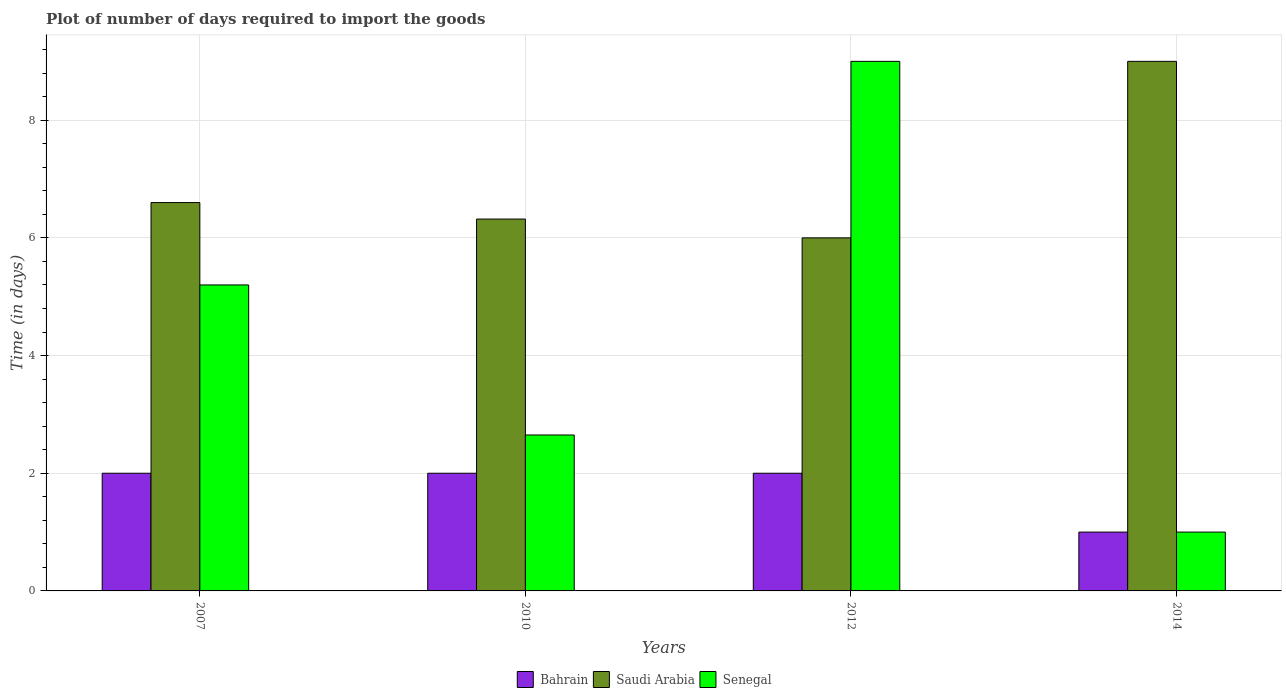How many groups of bars are there?
Offer a terse response. 4. How many bars are there on the 3rd tick from the left?
Your response must be concise. 3. In how many cases, is the number of bars for a given year not equal to the number of legend labels?
Keep it short and to the point. 0. Across all years, what is the maximum time required to import goods in Senegal?
Make the answer very short. 9. Across all years, what is the minimum time required to import goods in Bahrain?
Ensure brevity in your answer.  1. What is the total time required to import goods in Bahrain in the graph?
Your answer should be very brief. 7. What is the difference between the time required to import goods in Bahrain in 2010 and that in 2014?
Ensure brevity in your answer.  1. What is the average time required to import goods in Senegal per year?
Your answer should be very brief. 4.46. In the year 2012, what is the difference between the time required to import goods in Bahrain and time required to import goods in Saudi Arabia?
Keep it short and to the point. -4. In how many years, is the time required to import goods in Saudi Arabia greater than 7.6 days?
Your answer should be compact. 1. What is the ratio of the time required to import goods in Senegal in 2012 to that in 2014?
Give a very brief answer. 9. Is the difference between the time required to import goods in Bahrain in 2010 and 2014 greater than the difference between the time required to import goods in Saudi Arabia in 2010 and 2014?
Offer a terse response. Yes. What does the 1st bar from the left in 2012 represents?
Your answer should be very brief. Bahrain. What does the 2nd bar from the right in 2010 represents?
Offer a very short reply. Saudi Arabia. Is it the case that in every year, the sum of the time required to import goods in Saudi Arabia and time required to import goods in Senegal is greater than the time required to import goods in Bahrain?
Your response must be concise. Yes. Are all the bars in the graph horizontal?
Offer a terse response. No. How many years are there in the graph?
Your answer should be compact. 4. What is the difference between two consecutive major ticks on the Y-axis?
Ensure brevity in your answer.  2. Does the graph contain any zero values?
Ensure brevity in your answer.  No. Does the graph contain grids?
Your answer should be very brief. Yes. Where does the legend appear in the graph?
Provide a short and direct response. Bottom center. How many legend labels are there?
Ensure brevity in your answer.  3. What is the title of the graph?
Offer a very short reply. Plot of number of days required to import the goods. What is the label or title of the Y-axis?
Keep it short and to the point. Time (in days). What is the Time (in days) of Bahrain in 2007?
Ensure brevity in your answer.  2. What is the Time (in days) of Saudi Arabia in 2007?
Ensure brevity in your answer.  6.6. What is the Time (in days) in Saudi Arabia in 2010?
Make the answer very short. 6.32. What is the Time (in days) in Senegal in 2010?
Your response must be concise. 2.65. What is the Time (in days) in Bahrain in 2012?
Provide a succinct answer. 2. What is the Time (in days) in Saudi Arabia in 2012?
Offer a terse response. 6. What is the Time (in days) in Saudi Arabia in 2014?
Provide a succinct answer. 9. What is the Time (in days) of Senegal in 2014?
Provide a short and direct response. 1. Across all years, what is the maximum Time (in days) of Bahrain?
Give a very brief answer. 2. Across all years, what is the maximum Time (in days) in Saudi Arabia?
Keep it short and to the point. 9. Across all years, what is the minimum Time (in days) of Bahrain?
Provide a succinct answer. 1. Across all years, what is the minimum Time (in days) of Saudi Arabia?
Offer a very short reply. 6. Across all years, what is the minimum Time (in days) of Senegal?
Your response must be concise. 1. What is the total Time (in days) of Saudi Arabia in the graph?
Offer a very short reply. 27.92. What is the total Time (in days) in Senegal in the graph?
Give a very brief answer. 17.85. What is the difference between the Time (in days) in Bahrain in 2007 and that in 2010?
Offer a terse response. 0. What is the difference between the Time (in days) in Saudi Arabia in 2007 and that in 2010?
Your answer should be compact. 0.28. What is the difference between the Time (in days) in Senegal in 2007 and that in 2010?
Offer a very short reply. 2.55. What is the difference between the Time (in days) of Senegal in 2007 and that in 2012?
Your answer should be compact. -3.8. What is the difference between the Time (in days) of Saudi Arabia in 2007 and that in 2014?
Your response must be concise. -2.4. What is the difference between the Time (in days) in Senegal in 2007 and that in 2014?
Keep it short and to the point. 4.2. What is the difference between the Time (in days) in Saudi Arabia in 2010 and that in 2012?
Make the answer very short. 0.32. What is the difference between the Time (in days) in Senegal in 2010 and that in 2012?
Offer a very short reply. -6.35. What is the difference between the Time (in days) in Bahrain in 2010 and that in 2014?
Make the answer very short. 1. What is the difference between the Time (in days) in Saudi Arabia in 2010 and that in 2014?
Provide a short and direct response. -2.68. What is the difference between the Time (in days) of Senegal in 2010 and that in 2014?
Make the answer very short. 1.65. What is the difference between the Time (in days) in Bahrain in 2012 and that in 2014?
Ensure brevity in your answer.  1. What is the difference between the Time (in days) in Bahrain in 2007 and the Time (in days) in Saudi Arabia in 2010?
Your answer should be compact. -4.32. What is the difference between the Time (in days) in Bahrain in 2007 and the Time (in days) in Senegal in 2010?
Ensure brevity in your answer.  -0.65. What is the difference between the Time (in days) in Saudi Arabia in 2007 and the Time (in days) in Senegal in 2010?
Your answer should be compact. 3.95. What is the difference between the Time (in days) of Bahrain in 2007 and the Time (in days) of Saudi Arabia in 2012?
Ensure brevity in your answer.  -4. What is the difference between the Time (in days) in Bahrain in 2007 and the Time (in days) in Senegal in 2012?
Your answer should be compact. -7. What is the difference between the Time (in days) in Bahrain in 2010 and the Time (in days) in Saudi Arabia in 2012?
Give a very brief answer. -4. What is the difference between the Time (in days) of Bahrain in 2010 and the Time (in days) of Senegal in 2012?
Provide a succinct answer. -7. What is the difference between the Time (in days) in Saudi Arabia in 2010 and the Time (in days) in Senegal in 2012?
Provide a succinct answer. -2.68. What is the difference between the Time (in days) in Saudi Arabia in 2010 and the Time (in days) in Senegal in 2014?
Provide a succinct answer. 5.32. What is the difference between the Time (in days) of Bahrain in 2012 and the Time (in days) of Saudi Arabia in 2014?
Your answer should be compact. -7. What is the average Time (in days) in Saudi Arabia per year?
Make the answer very short. 6.98. What is the average Time (in days) of Senegal per year?
Provide a short and direct response. 4.46. In the year 2007, what is the difference between the Time (in days) in Bahrain and Time (in days) in Senegal?
Provide a short and direct response. -3.2. In the year 2007, what is the difference between the Time (in days) in Saudi Arabia and Time (in days) in Senegal?
Your answer should be very brief. 1.4. In the year 2010, what is the difference between the Time (in days) in Bahrain and Time (in days) in Saudi Arabia?
Offer a terse response. -4.32. In the year 2010, what is the difference between the Time (in days) in Bahrain and Time (in days) in Senegal?
Offer a very short reply. -0.65. In the year 2010, what is the difference between the Time (in days) in Saudi Arabia and Time (in days) in Senegal?
Your answer should be compact. 3.67. In the year 2012, what is the difference between the Time (in days) of Bahrain and Time (in days) of Saudi Arabia?
Make the answer very short. -4. In the year 2014, what is the difference between the Time (in days) of Bahrain and Time (in days) of Saudi Arabia?
Ensure brevity in your answer.  -8. What is the ratio of the Time (in days) of Saudi Arabia in 2007 to that in 2010?
Offer a very short reply. 1.04. What is the ratio of the Time (in days) in Senegal in 2007 to that in 2010?
Keep it short and to the point. 1.96. What is the ratio of the Time (in days) in Bahrain in 2007 to that in 2012?
Make the answer very short. 1. What is the ratio of the Time (in days) of Senegal in 2007 to that in 2012?
Your response must be concise. 0.58. What is the ratio of the Time (in days) of Saudi Arabia in 2007 to that in 2014?
Provide a succinct answer. 0.73. What is the ratio of the Time (in days) in Saudi Arabia in 2010 to that in 2012?
Offer a very short reply. 1.05. What is the ratio of the Time (in days) of Senegal in 2010 to that in 2012?
Give a very brief answer. 0.29. What is the ratio of the Time (in days) in Saudi Arabia in 2010 to that in 2014?
Offer a terse response. 0.7. What is the ratio of the Time (in days) of Senegal in 2010 to that in 2014?
Your answer should be compact. 2.65. What is the ratio of the Time (in days) in Bahrain in 2012 to that in 2014?
Your answer should be very brief. 2. What is the difference between the highest and the second highest Time (in days) of Saudi Arabia?
Make the answer very short. 2.4. What is the difference between the highest and the lowest Time (in days) of Saudi Arabia?
Your answer should be very brief. 3. What is the difference between the highest and the lowest Time (in days) of Senegal?
Offer a terse response. 8. 